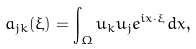<formula> <loc_0><loc_0><loc_500><loc_500>a _ { j k } ( \xi ) = \int _ { \Omega } u _ { k } u _ { j } e ^ { i x \cdot \xi } d x ,</formula> 